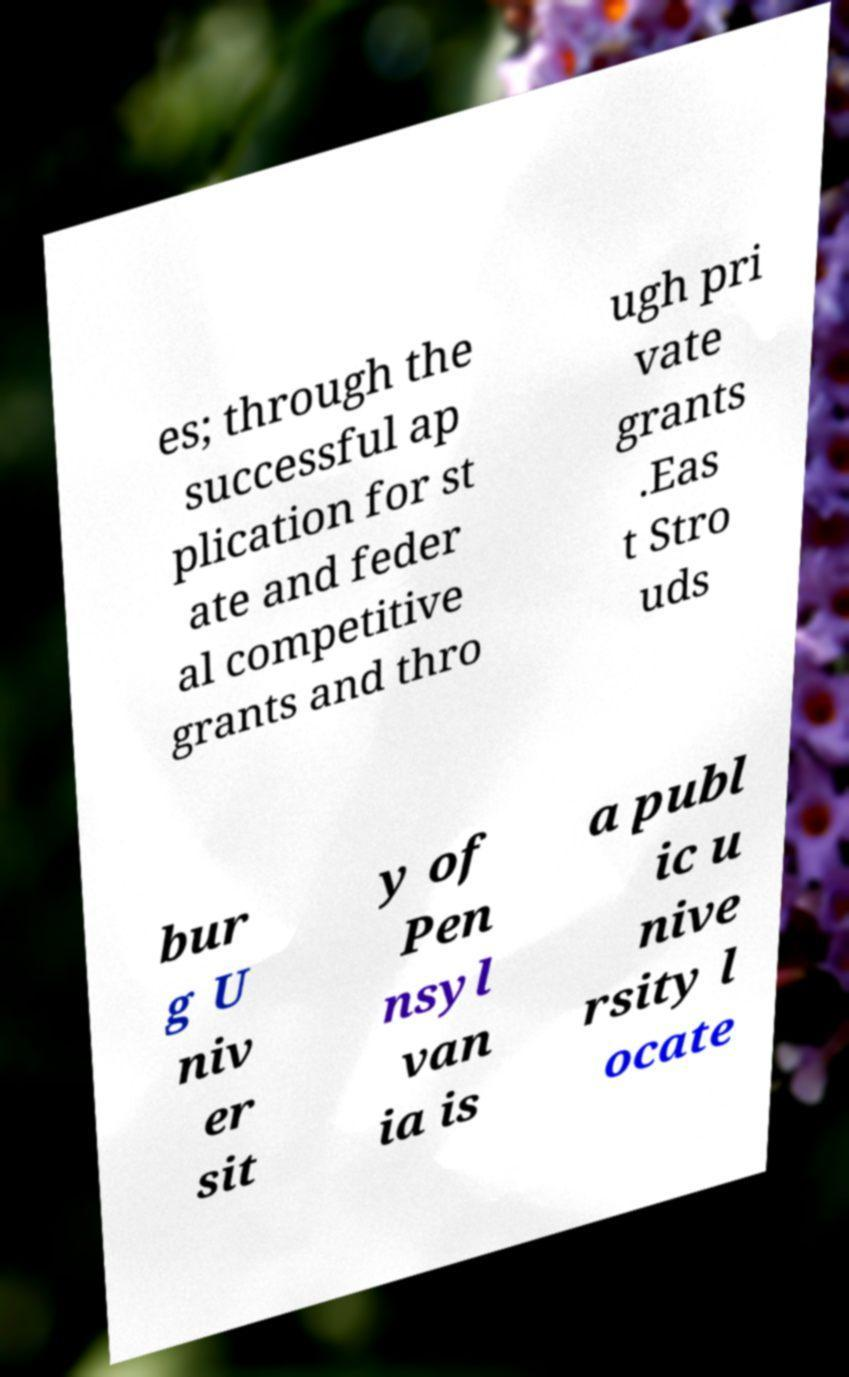Please identify and transcribe the text found in this image. es; through the successful ap plication for st ate and feder al competitive grants and thro ugh pri vate grants .Eas t Stro uds bur g U niv er sit y of Pen nsyl van ia is a publ ic u nive rsity l ocate 